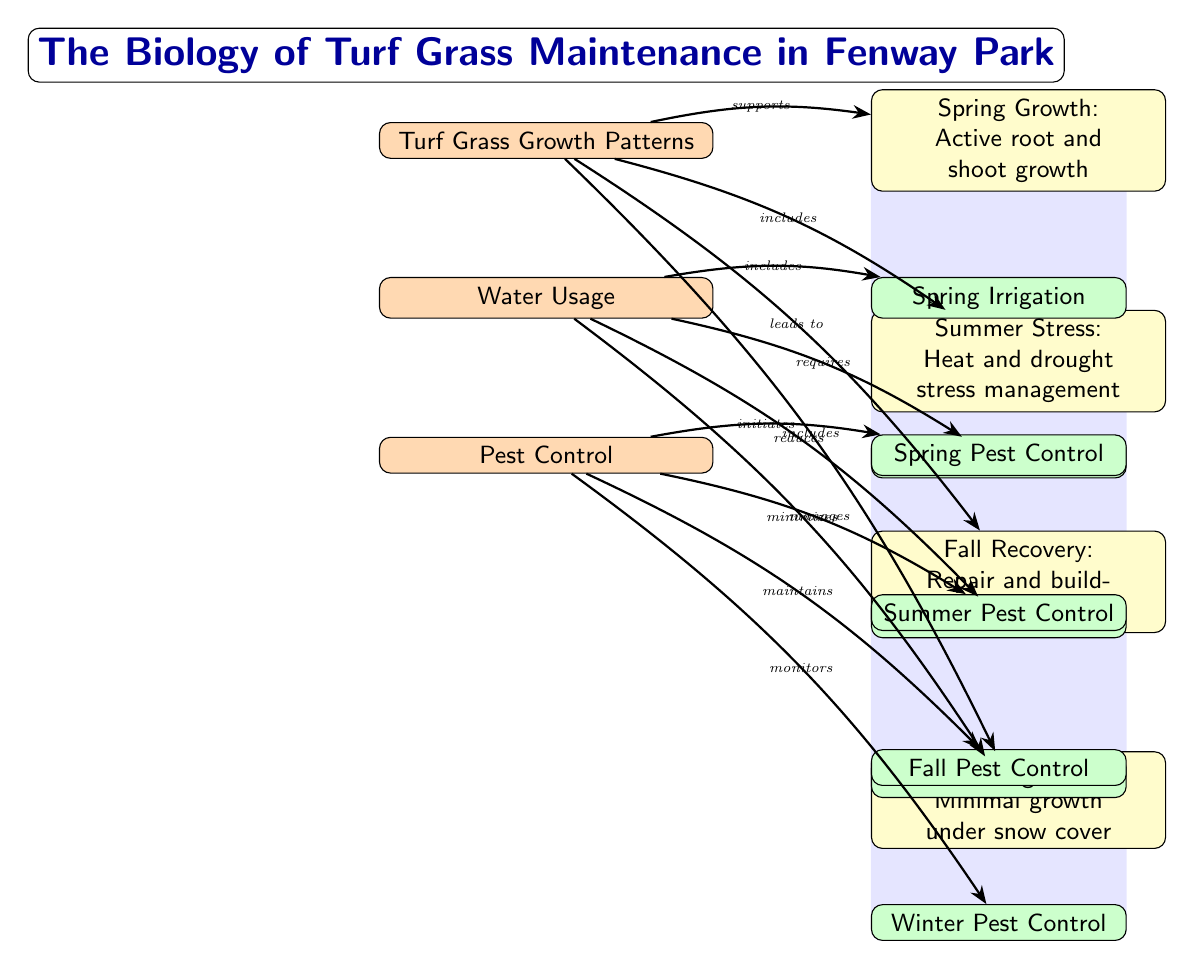What are the four main sections of the diagram? The diagram is divided into three main sections: Turf Grass Growth Patterns, Water Usage, and Pest Control.
Answer: Turf Grass Growth Patterns, Water Usage, Pest Control Which growth pattern occurs during the summer? The diagram indicates that the summer growth pattern is labeled as "Summer Stress: Heat and drought stress management."
Answer: Summer Stress: Heat and drought stress management What type of arrow connects 'Water Usage' to 'Summer Irrigation'? The arrow connecting these two nodes is labeled "requires," which indicates that water usage requires summer irrigation for effective grass maintenance.
Answer: requires How many seasonal pest control strategies are depicted in the diagram? The diagram shows a total of four seasonal pest control strategies: Spring Pest Control, Summer Pest Control, Fall Pest Control, and Winter Pest Control.
Answer: 4 How does pest control support grass growth in spring? The diagram indicates that pest control initiates Spring Pest Control, which supports the overall growth of turf grass in the spring season.
Answer: initiates What does winter irrigation do according to the diagram? According to the diagram, winter irrigation is labeled as "minimizes," which suggests a reduced need for active watering during the winter months.
Answer: minimizes What seasonal irrigation activity is noted in the diagram for the fall? The diagram mentions "Fall Irrigation" under the Water Usage section, indicating it is a specific activity during that season.
Answer: Fall Irrigation Which growth pattern indicates minimal growth? The winter growth pattern is described as "Winter Dormancy: Minimal growth under snow cover," clearly stating its characteristic of growth limitation.
Answer: Winter Dormancy: Minimal growth under snow cover What relationship does 'Turf Grass Growth Patterns' have with 'Winter Dormancy'? The diagram specifies that 'Turf Grass Growth Patterns' leads to 'Winter Dormancy', illustrating the transition from growth to dormancy in the winter.
Answer: leads to 